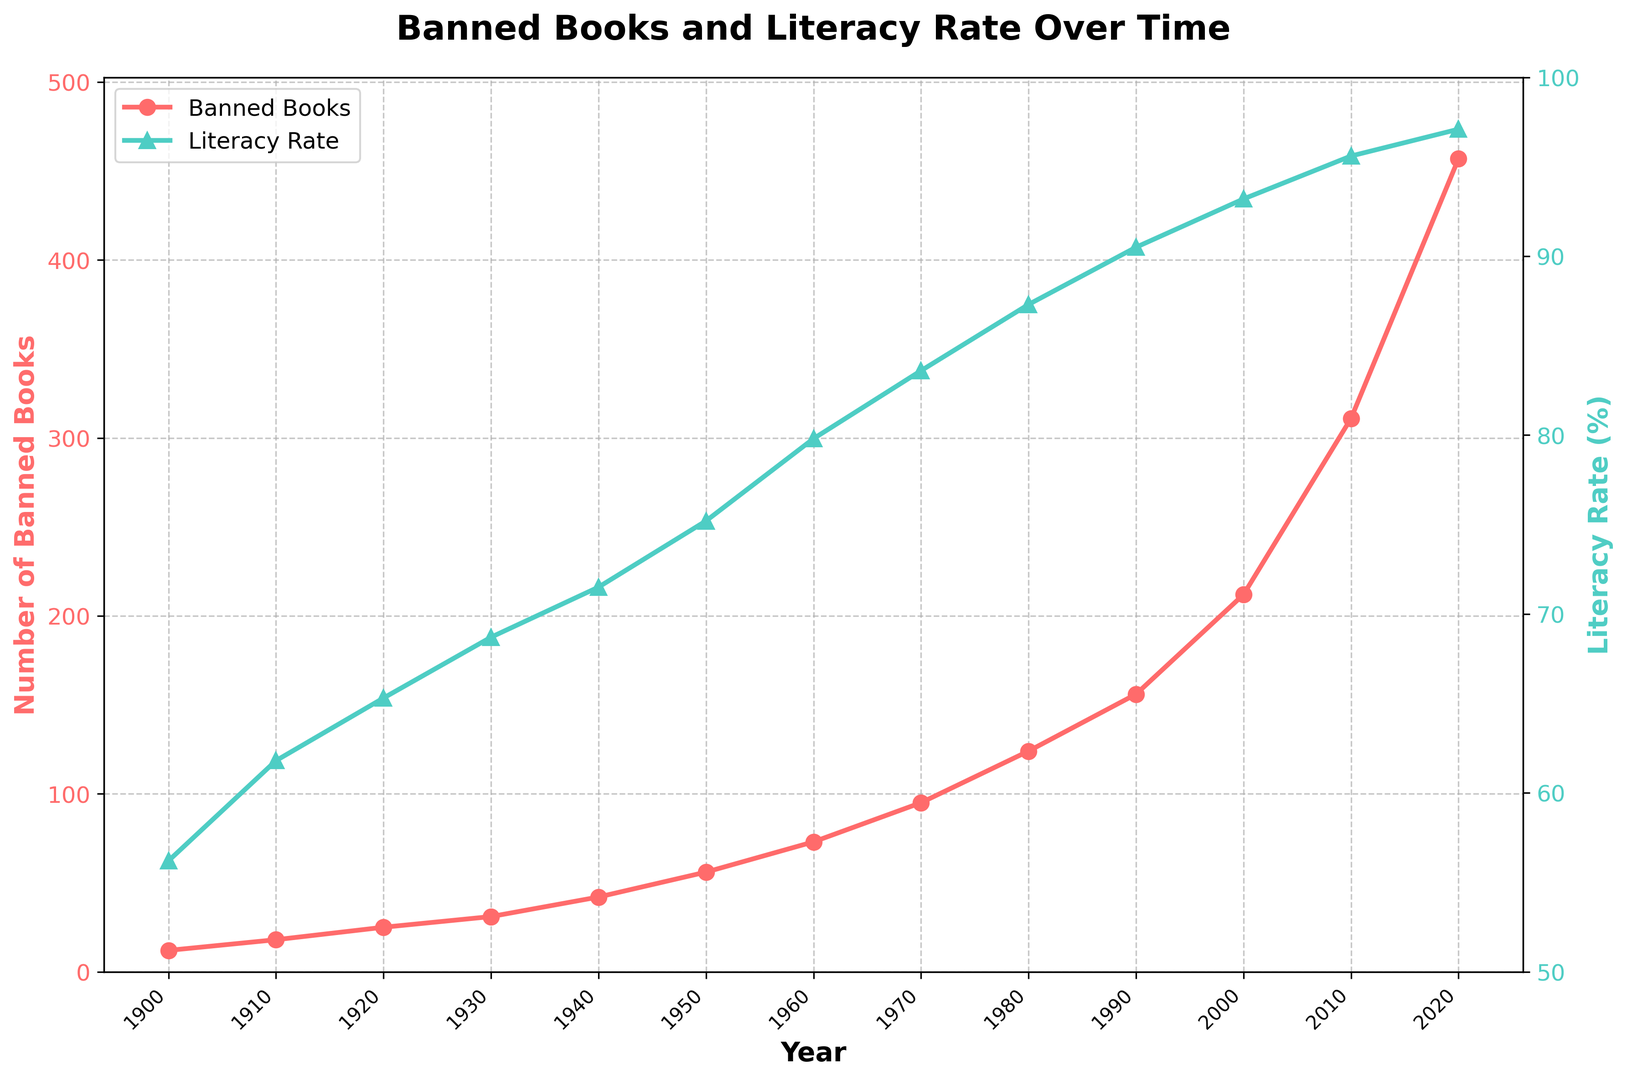How does the frequency of banned books in 1920 compare to that in 2020? By examining the graph, you can see the number of banned books in 1920 is given directly as 25. For 2020, it is given directly as 457. Since 457 is significantly greater than 25, the frequency has increased.
Answer: The number of banned books in 2020 is significantly greater than in 1920 What is the difference in literacy rate between 1930 and 1970? By looking at the graph, the literacy rate in 1930 is shown as 68.7%, and in 1970 it is 83.6%. Subtracting the two gives: \(83.6\% - 68.7\% = 14.9\%\)
Answer: 14.9% By how much did the number of banned books increase from 2000 to 2010? According to the plot, the number of banned books in 2000 was 212 and in 2010 it was 311. The increase is calculated by subtracting the earlier value from the later value: \(311 - 212 = 99\)
Answer: 99 What trends can you observe in the relationship between banned books and literacy rate over the entire period? From the graph, we see a general trend where both the number of banned books and literacy rate increase over time. Despite varying years, there isn't a clear pattern where an increase in one directly corresponds with a decrease in the other or vice versa. Both metrics showed consistent growth.
Answer: Both metrics increase over time What are the minimum and maximum values of banned books recorded in the plot? The minimum value of banned books is 12 in 1900, and the maximum value is 457 in 2020.
Answer: Minimum: 12, Maximum: 457 How did the number of banned books change between 1990 and 2000? The number of banned books in 1990 was 156, and in 2000 it was 212. The change is calculated by subtracting the earlier value from the later value: \(212 - 156 = 56\)
Answer: Increase by 56 What is the average literacy rate across the entire period? To find the average literacy rate, sum all the literacy rates and divide by the number of data points.
\[
\frac{56.2 + 61.8 + 65.3 + 68.7 + 71.5 + 75.2 + 79.8 + 83.6 + 87.3 + 90.5 + 93.2 + 95.6 + 97.1}{13} = \frac{1025.8}{13} ≈ 78.9
\]
Answer: 78.9% What visual clues indicate the primary and secondary variables in the graph? The primary variable (banned books) is indicated by the red line with circular markers and the y-axis on the left. The secondary variable (literacy rate) is indicated by the green line with triangular markers and the y-axis on the right. These visual differences distinguish the two variables.
Answer: Red line for banned books, green line for literacy rate 